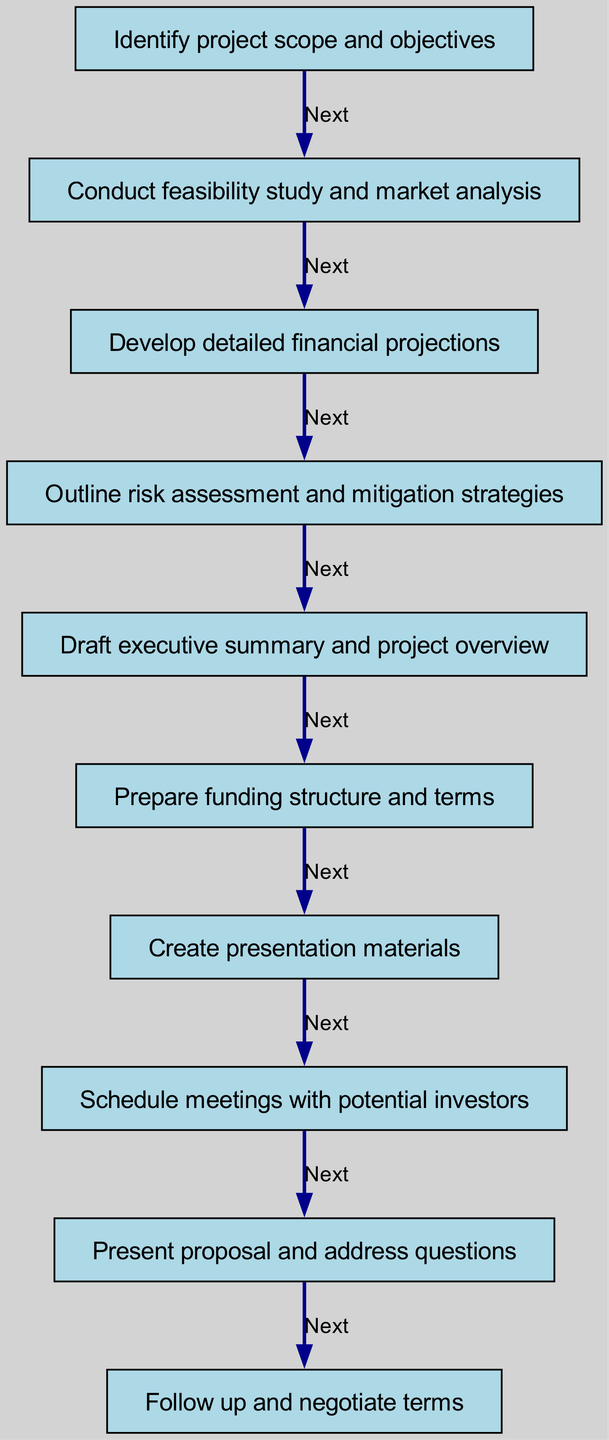What is the first step in developing a funding proposal? The first step mentioned in the diagram is "Identify project scope and objectives." This is indicated as the starting node of the flowchart.
Answer: Identify project scope and objectives How many total steps are outlined in the diagram? The diagram lists a total of 10 distinct steps from start to finish, as each entry corresponds to one step in the process.
Answer: 10 What is the last step of the proposal process? The last step indicated in the flowchart is "Follow up and negotiate terms," which can be found at the end of the sequence of arrows.
Answer: Follow up and negotiate terms What step comes immediately after conducting a feasibility study? After "Conduct feasibility study and market analysis," the next step specified is "Develop detailed financial projections." This is a direct progression shown in the diagram.
Answer: Develop detailed financial projections What is the relationship between the steps "Create presentation materials" and "Schedule meetings with potential investors"? The relationship is sequential, where "Create presentation materials" directly leads to "Schedule meetings with potential investors," signifying that the presentation materials must be prepared before the meetings are set.
Answer: Sequential relationship Which step emphasizes risk assessment? The step that emphasizes risk assessment is "Outline risk assessment and mitigation strategies," clearly outlined in the diagram as focused on addressing risks associated with the project.
Answer: Outline risk assessment and mitigation strategies What step is directly before preparing the funding structure? The step directly preceding this is "Draft executive summary and project overview," indicating that summarizing the project is necessary before detailing funding structures.
Answer: Draft executive summary and project overview How many steps involve preparing documents or materials? There are three steps that involve preparing documents or materials: "Draft executive summary and project overview," "Prepare funding structure and terms," and "Create presentation materials." These focus on documentation preparation throughout the process.
Answer: 3 What action is taken during the last step in the diagram? The last action taken is to "Follow up and negotiate terms," indicating that the final activity involves communication and negotiation regarding the proposal.
Answer: Follow up and negotiate terms 